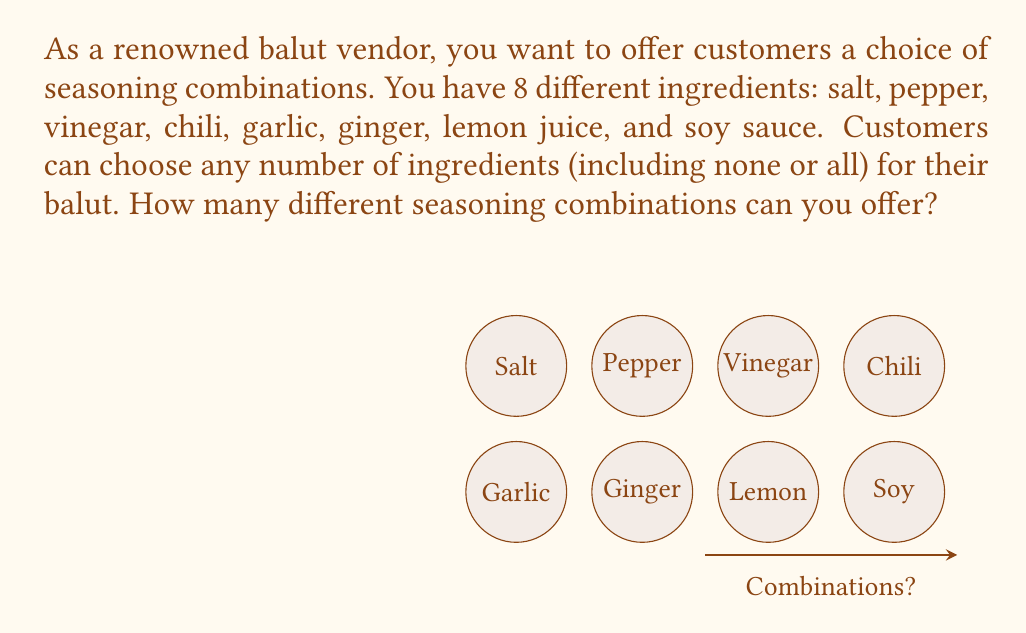Can you answer this question? To solve this problem, we need to use the concept of power sets in combinatorics.

1) Each ingredient can be either included or not included in a combination. This means for each ingredient, we have 2 choices.

2) We have 8 different ingredients in total.

3) The number of ways to make choices for all 8 ingredients is the product of the number of choices for each ingredient.

4) This can be represented mathematically as $2^8$, because we're making 2 choices (include or not) for each of the 8 ingredients.

5) To calculate $2^8$:

   $$2^8 = 2 \times 2 \times 2 \times 2 \times 2 \times 2 \times 2 \times 2 = 256$$

6) This includes the combination where no ingredients are chosen (an empty set) and the combination where all ingredients are chosen.

Therefore, the total number of different seasoning combinations you can offer is 256.
Answer: $2^8 = 256$ combinations 